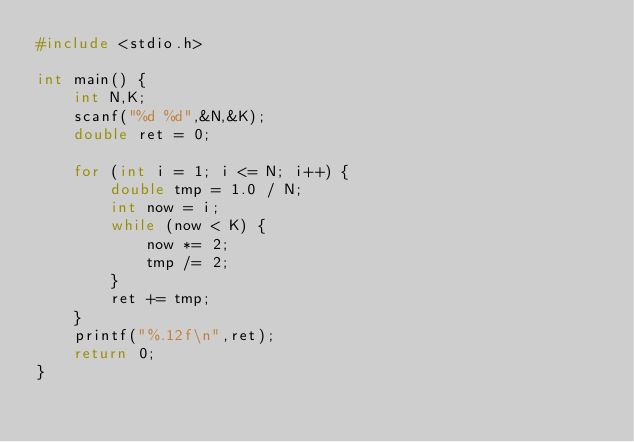Convert code to text. <code><loc_0><loc_0><loc_500><loc_500><_C_>#include <stdio.h>

int main() {
	int N,K;
	scanf("%d %d",&N,&K);
	double ret = 0;

	for (int i = 1; i <= N; i++) {
		double tmp = 1.0 / N;
		int now = i;
		while (now < K) {
			now *= 2;
			tmp /= 2;
		}
		ret += tmp;
	}
	printf("%.12f\n",ret);
	return 0;
}</code> 